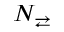<formula> <loc_0><loc_0><loc_500><loc_500>N _ { \right l e f t a r r o w s }</formula> 